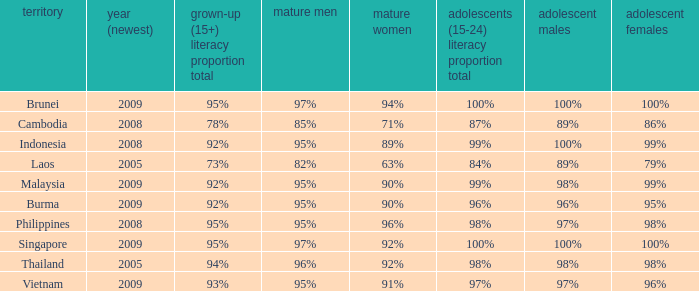Which country has its most recent year as being 2005 and has an Adult Men literacy rate of 96%? Thailand. 